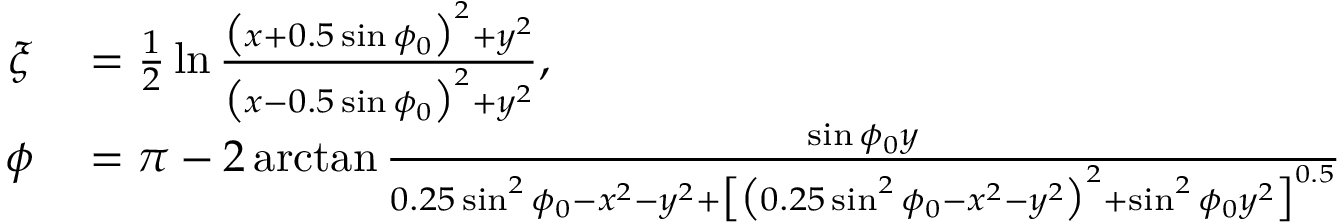Convert formula to latex. <formula><loc_0><loc_0><loc_500><loc_500>\begin{array} { r l } { \xi } & = \frac { 1 } { 2 } \ln \frac { \left ( x + 0 . 5 \sin \phi _ { 0 } \right ) ^ { 2 } + y ^ { 2 } } { \left ( x - 0 . 5 \sin \phi _ { 0 } \right ) ^ { 2 } + y ^ { 2 } } , } \\ { \phi } & = \pi - 2 \arctan \frac { \sin \phi _ { 0 } y } { 0 . 2 5 \sin ^ { 2 } \phi _ { 0 } - x ^ { 2 } - y ^ { 2 } + \left [ \left ( 0 . 2 5 \sin ^ { 2 } \phi _ { 0 } - x ^ { 2 } - y ^ { 2 } \right ) ^ { 2 } + \sin ^ { 2 } \phi _ { 0 } y ^ { 2 } \right ] ^ { 0 . 5 } } } \end{array}</formula> 